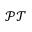<formula> <loc_0><loc_0><loc_500><loc_500>\mathcal { P T }</formula> 